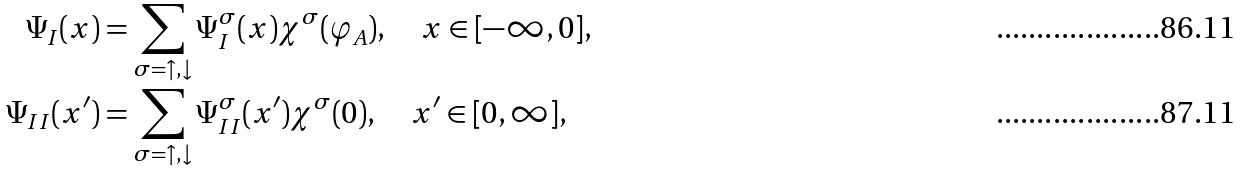<formula> <loc_0><loc_0><loc_500><loc_500>\Psi _ { I } ( x ) & = \sum _ { \sigma = \uparrow , \downarrow } \Psi _ { I } ^ { \sigma } ( x ) \chi ^ { \sigma } ( \varphi _ { A } ) , \quad x \in [ - \infty , 0 ] , \\ \Psi _ { I I } ( x ^ { \prime } ) & = \sum _ { \sigma = \uparrow , \downarrow } \Psi _ { I I } ^ { \sigma } ( x ^ { \prime } ) \chi ^ { \sigma } ( 0 ) , \quad x ^ { \prime } \in [ 0 , \infty ] ,</formula> 